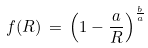Convert formula to latex. <formula><loc_0><loc_0><loc_500><loc_500>f ( R ) \, = \, { \left ( 1 - \frac { a } { R } \right ) } ^ { \frac { b } { a } }</formula> 